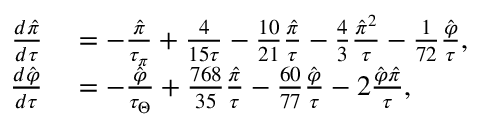<formula> <loc_0><loc_0><loc_500><loc_500>\begin{array} { r l } { \frac { d \hat { \pi } } { d \tau } } & = - \frac { \hat { \pi } } { \tau _ { \pi } } + \frac { 4 } { 1 5 \tau } - \frac { 1 0 } { 2 1 } \frac { \hat { \pi } } { \tau } - \frac { 4 } { 3 } \frac { \hat { \pi } ^ { 2 } } { \tau } - \frac { 1 } { 7 2 } \frac { \hat { \varphi } } { \tau } , } \\ { \frac { d \hat { \varphi } } { d \tau } } & = - \frac { \hat { \varphi } } { \tau _ { \Theta } } + \frac { 7 6 8 } { 3 5 } \frac { \hat { \pi } } { \tau } - \frac { 6 0 } { 7 7 } \frac { \hat { \varphi } } { \tau } - 2 \frac { \hat { \varphi } \hat { \pi } } { \tau } , } \end{array}</formula> 